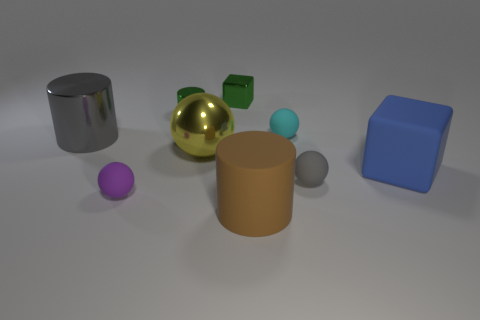How many objects in the image are spherical? There are two objects that are spherical in the image: a large reflective gold sphere and a smaller blue one. Can you guess the purpose of this arrangement of objects? While it's a bit speculative without more context, the arrangement of objects might be for a visual study of shapes, colors, and reflections, possibly for artistic or educational purposes. 